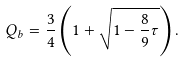<formula> <loc_0><loc_0><loc_500><loc_500>Q _ { b } = \frac { 3 } { 4 } \left ( 1 + \sqrt { 1 - \frac { 8 } { 9 } \tau } \right ) .</formula> 